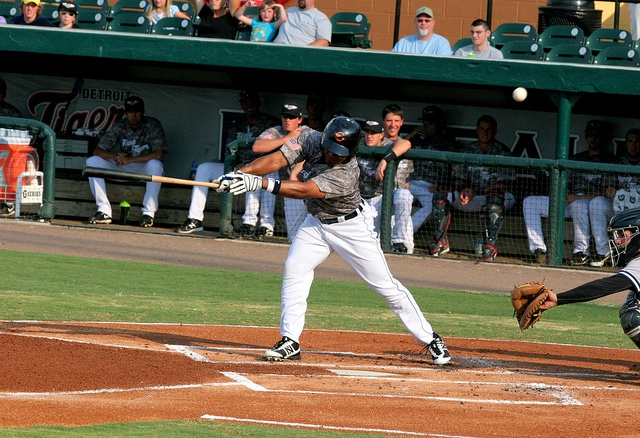Describe the objects in this image and their specific colors. I can see people in olive, black, lightgray, darkgray, and teal tones, people in olive, white, black, darkgray, and gray tones, people in olive, black, gray, and blue tones, people in olive, black, gray, and lightgray tones, and people in olive, black, and gray tones in this image. 